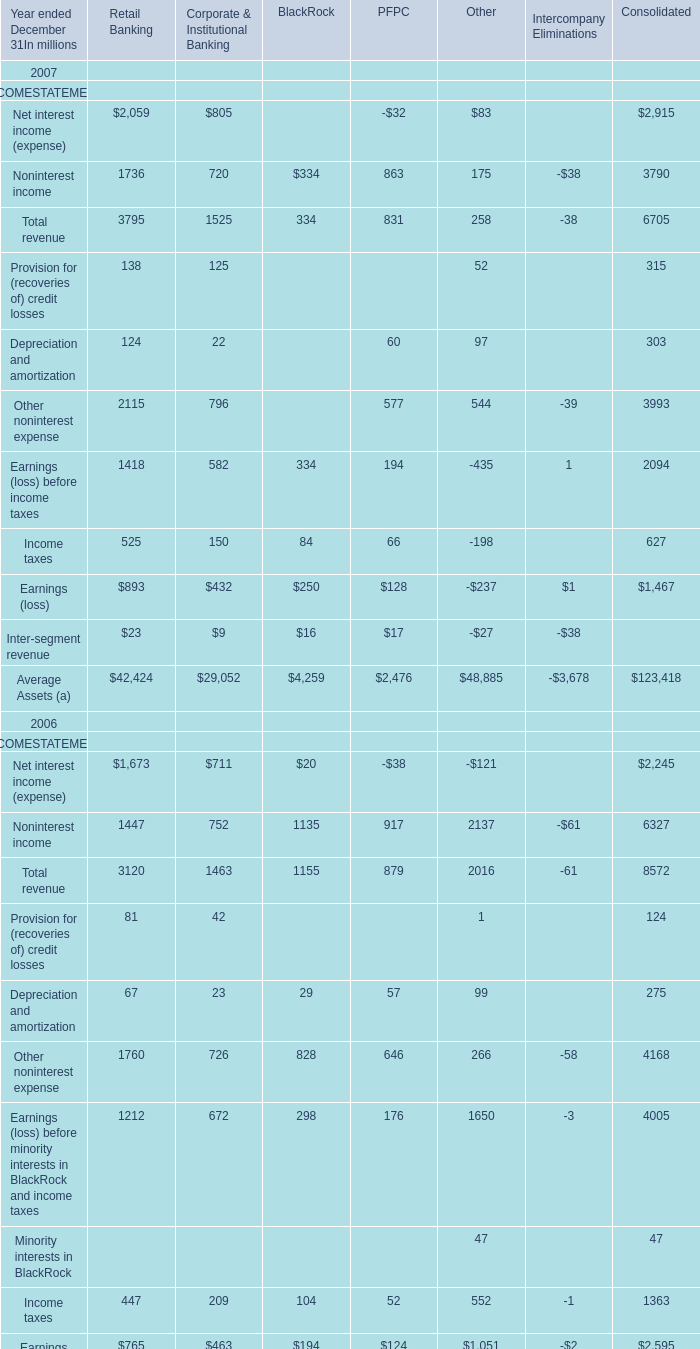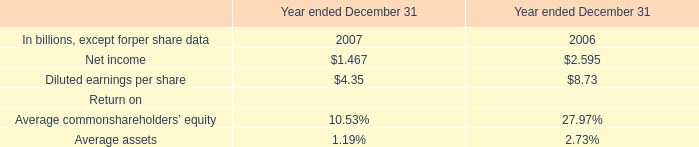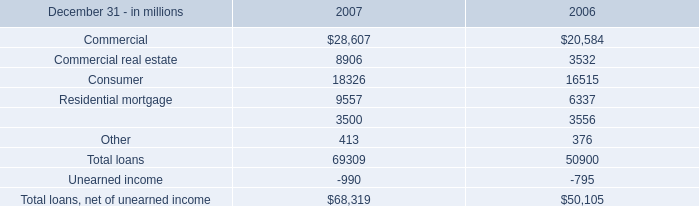For 2007 ended December 31,what is the value of Noninterest income for Corporate & Institutional Banking? (in million) 
Answer: 720. 